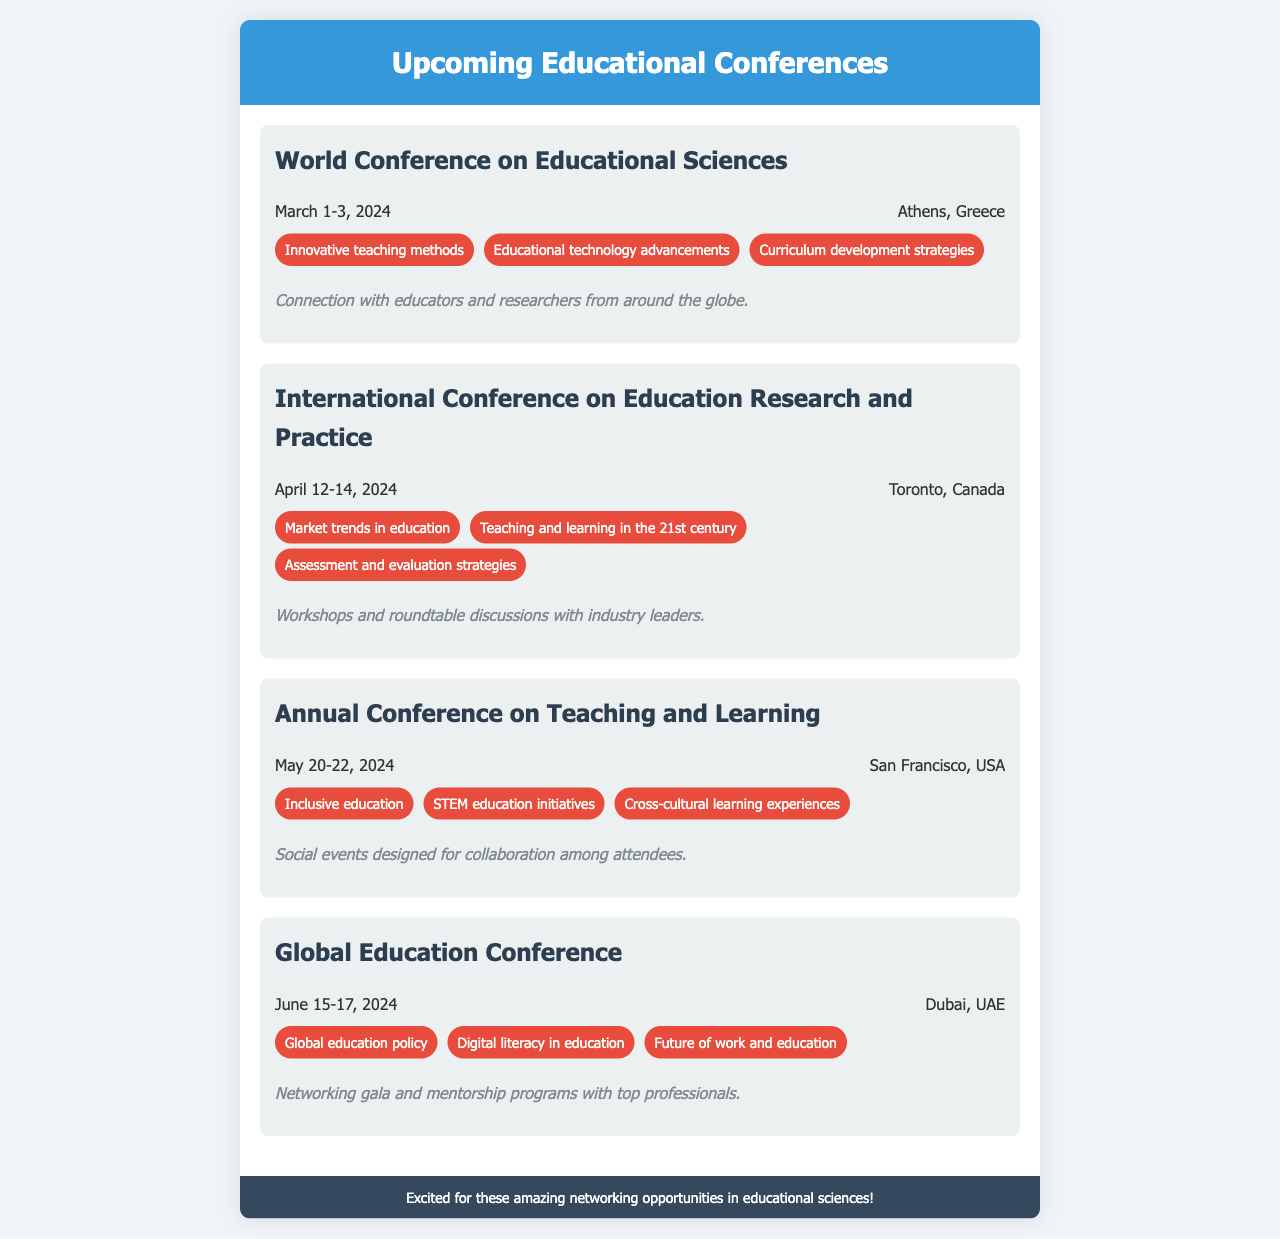what is the date of the World Conference on Educational Sciences? The date is mentioned in the document, which is March 1-3, 2024.
Answer: March 1-3, 2024 where is the International Conference on Education Research and Practice located? The location is specified in the document as Toronto, Canada.
Answer: Toronto, Canada what are the topics for the Annual Conference on Teaching and Learning? The topics are listed in the document: Inclusive education, STEM education initiatives, and Cross-cultural learning experiences.
Answer: Inclusive education, STEM education initiatives, Cross-cultural learning experiences which conference focuses on digital literacy in education? The document specifies the topic related to digital literacy in education at the Global Education Conference.
Answer: Global Education Conference how many days does the Global Education Conference last? The duration of the conference is given in the document, which is two days, from June 15 to June 17, 2024.
Answer: Two days what networking opportunities are available at the World Conference on Educational Sciences? The document mentions connection with educators and researchers from around the globe as the networking opportunity.
Answer: Connection with educators and researchers from around the globe when is the Annual Conference on Teaching and Learning scheduled? The schedule is detailed in the document as May 20-22, 2024.
Answer: May 20-22, 2024 what is the main focus of the topics at the International Conference on Education Research and Practice? The document provides key topics: Market trends in education, Teaching and learning in the 21st century, Assessment and evaluation strategies.
Answer: Market trends in education, Teaching and learning in the 21st century, Assessment and evaluation strategies 